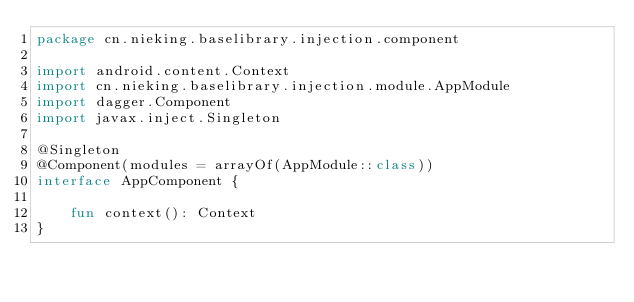<code> <loc_0><loc_0><loc_500><loc_500><_Kotlin_>package cn.nieking.baselibrary.injection.component

import android.content.Context
import cn.nieking.baselibrary.injection.module.AppModule
import dagger.Component
import javax.inject.Singleton

@Singleton
@Component(modules = arrayOf(AppModule::class))
interface AppComponent {

    fun context(): Context
}</code> 